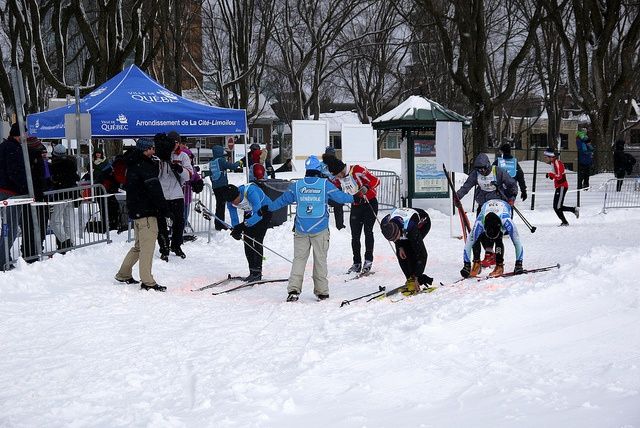Describe the objects in this image and their specific colors. I can see people in gray, black, lightgray, and darkgray tones, umbrella in gray, blue, and darkblue tones, people in gray, black, and lavender tones, people in gray, darkgray, blue, lightblue, and black tones, and people in gray, black, blue, and lightgray tones in this image. 